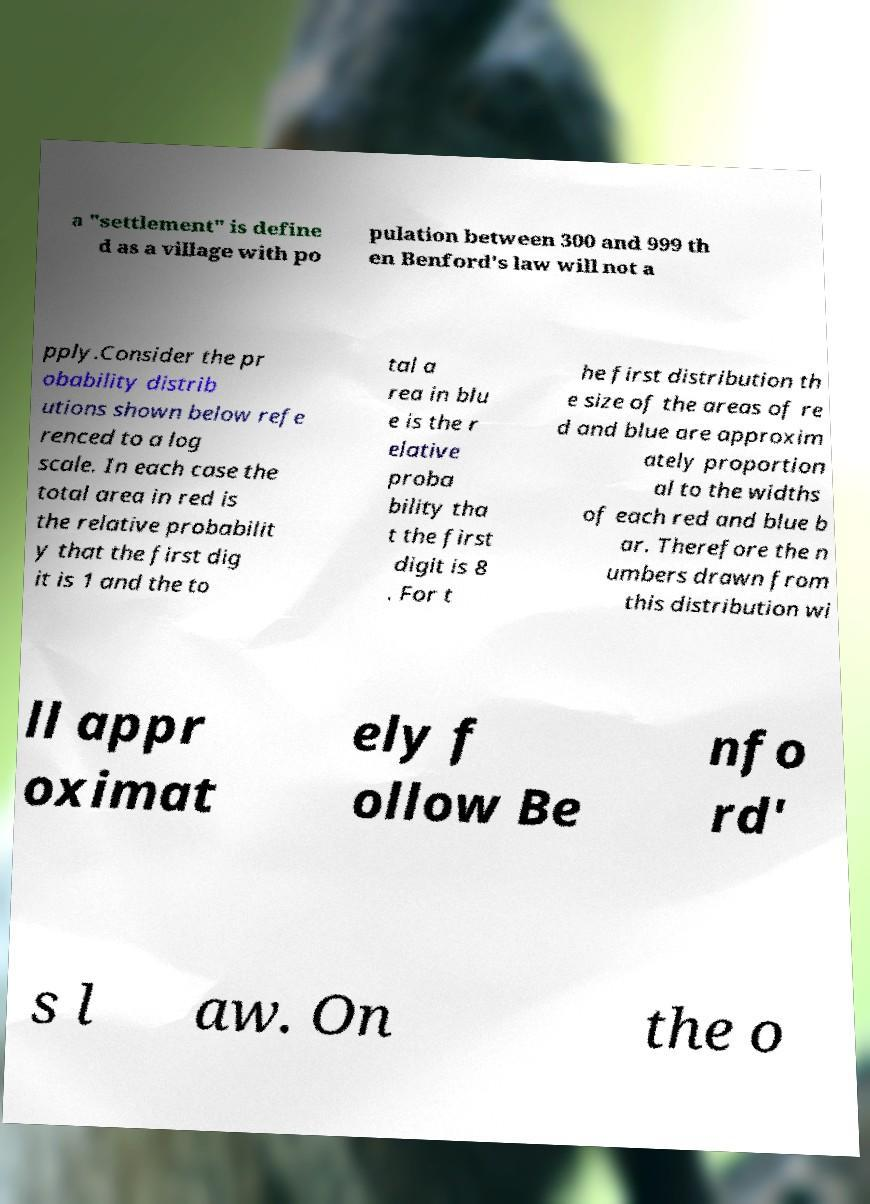For documentation purposes, I need the text within this image transcribed. Could you provide that? a "settlement" is define d as a village with po pulation between 300 and 999 th en Benford's law will not a pply.Consider the pr obability distrib utions shown below refe renced to a log scale. In each case the total area in red is the relative probabilit y that the first dig it is 1 and the to tal a rea in blu e is the r elative proba bility tha t the first digit is 8 . For t he first distribution th e size of the areas of re d and blue are approxim ately proportion al to the widths of each red and blue b ar. Therefore the n umbers drawn from this distribution wi ll appr oximat ely f ollow Be nfo rd' s l aw. On the o 